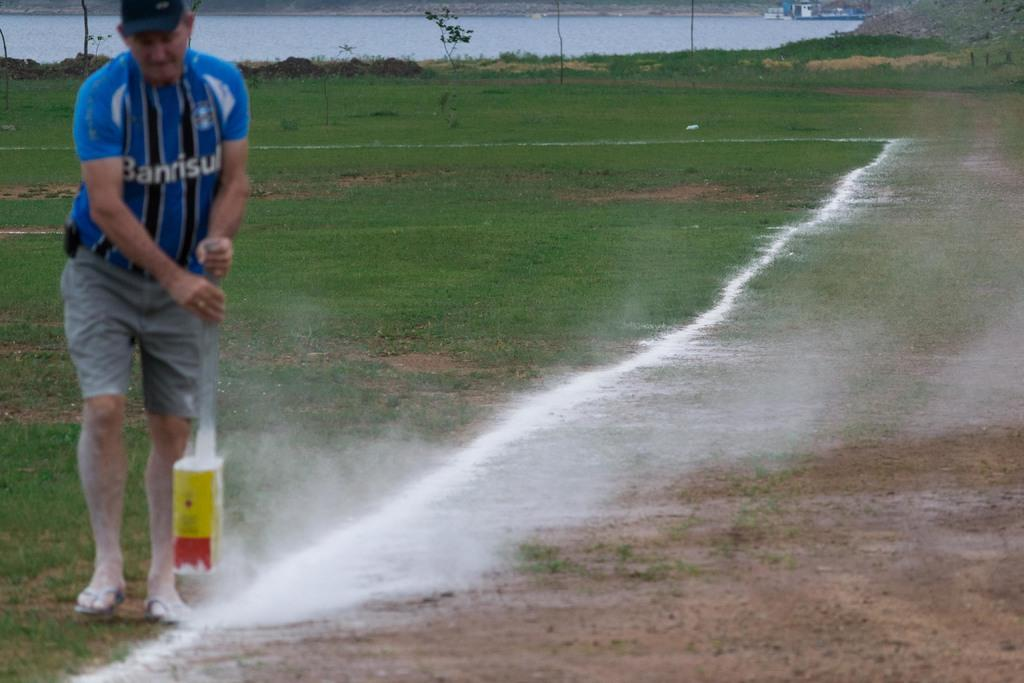Provide a one-sentence caption for the provided image. A man in a Banrisul striped shirt making a chalk line along a field. 